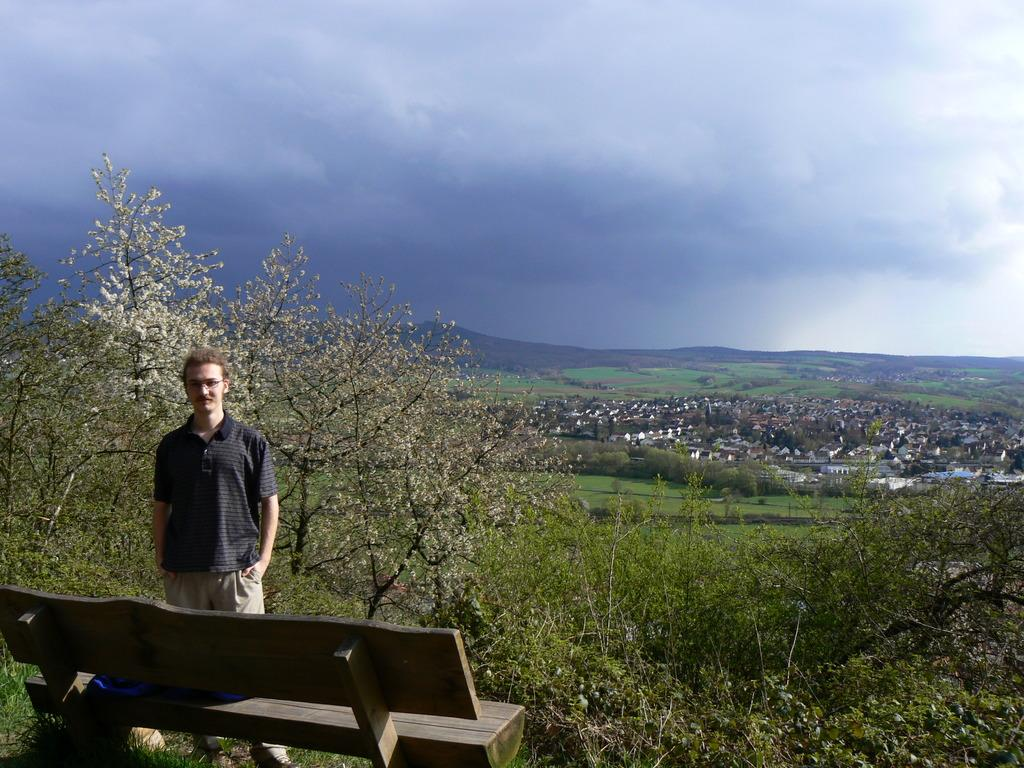What is the main subject of the image? There is a man standing in the image. Where is the man located in the image? The man is standing at a bench. What can be seen in the background of the image? There are trees, hills, the sky, clouds, grass, and houses visible in the background of the image. How many brothers does the man have, and are they present in the image? There is no information about the man's brothers in the image, so we cannot determine their presence or number. Is there a cactus visible in the image? No, there is no cactus present in the image. 